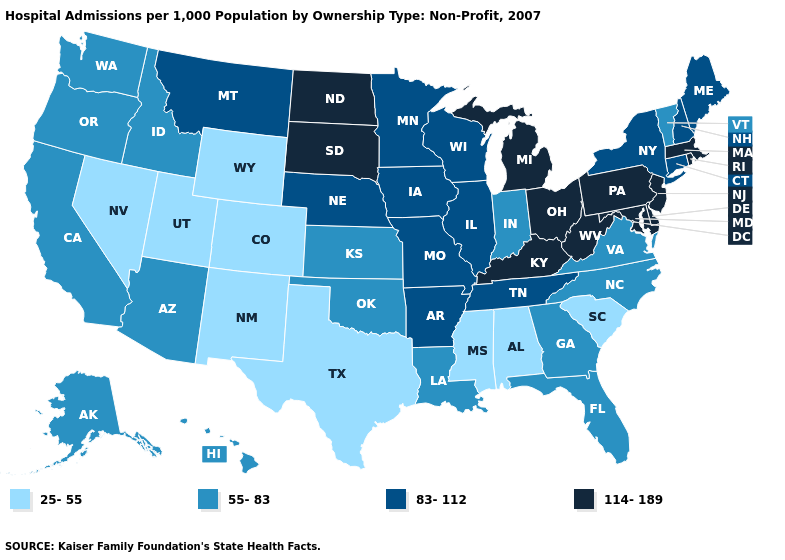Which states have the highest value in the USA?
Answer briefly. Delaware, Kentucky, Maryland, Massachusetts, Michigan, New Jersey, North Dakota, Ohio, Pennsylvania, Rhode Island, South Dakota, West Virginia. What is the value of Minnesota?
Quick response, please. 83-112. Name the states that have a value in the range 55-83?
Be succinct. Alaska, Arizona, California, Florida, Georgia, Hawaii, Idaho, Indiana, Kansas, Louisiana, North Carolina, Oklahoma, Oregon, Vermont, Virginia, Washington. Name the states that have a value in the range 114-189?
Short answer required. Delaware, Kentucky, Maryland, Massachusetts, Michigan, New Jersey, North Dakota, Ohio, Pennsylvania, Rhode Island, South Dakota, West Virginia. What is the value of Texas?
Be succinct. 25-55. What is the highest value in states that border Alabama?
Keep it brief. 83-112. Does Florida have a higher value than Wyoming?
Write a very short answer. Yes. Does Missouri have the highest value in the USA?
Give a very brief answer. No. Which states have the lowest value in the USA?
Give a very brief answer. Alabama, Colorado, Mississippi, Nevada, New Mexico, South Carolina, Texas, Utah, Wyoming. Does Idaho have a higher value than Alabama?
Short answer required. Yes. Name the states that have a value in the range 25-55?
Keep it brief. Alabama, Colorado, Mississippi, Nevada, New Mexico, South Carolina, Texas, Utah, Wyoming. Does Tennessee have the lowest value in the USA?
Answer briefly. No. Does New York have a higher value than Wisconsin?
Concise answer only. No. Which states have the lowest value in the USA?
Keep it brief. Alabama, Colorado, Mississippi, Nevada, New Mexico, South Carolina, Texas, Utah, Wyoming. Among the states that border Pennsylvania , which have the lowest value?
Concise answer only. New York. 